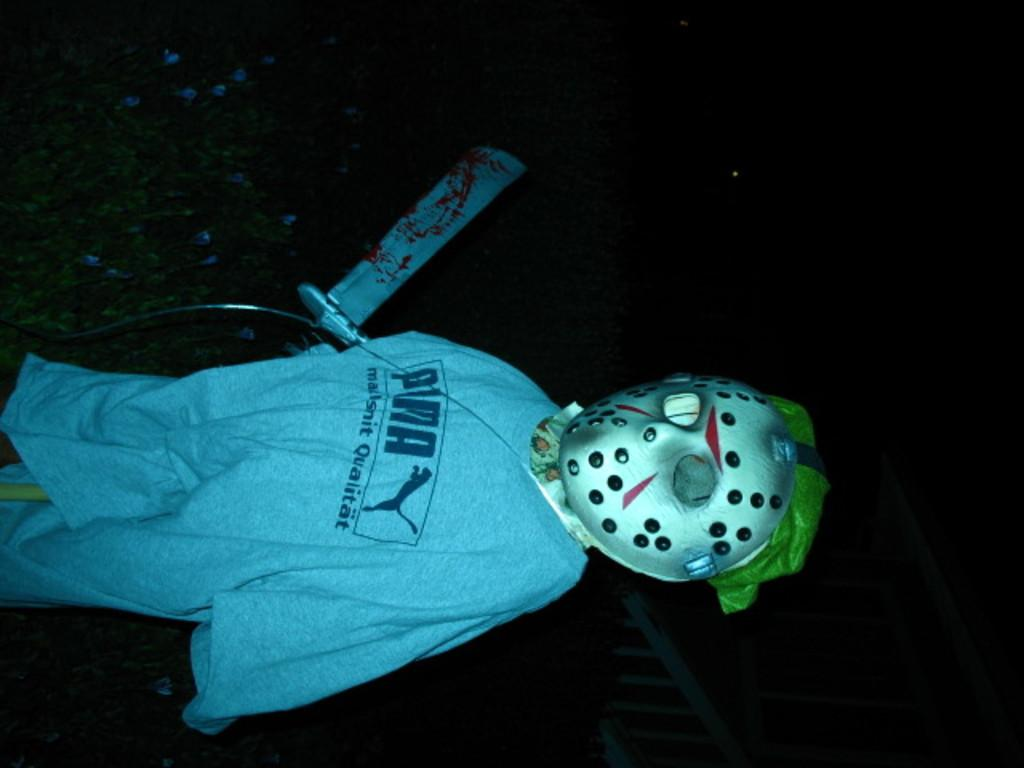What is the main subject of the image? There is a statue in the image. What can be observed about the statue's appearance? The statue has costumes. What type of natural elements can be seen in the background of the image? There are leaves in the background of the image. Can you describe an object in the image based on its color? There is an object in the image that is white in color. Can you tell me how many sofas are visible in the image? There are no sofas present in the image. What type of fish can be seen swimming in the stream in the image? There is no stream or fish present in the image; it features a statue with costumes and leaves in the background. 